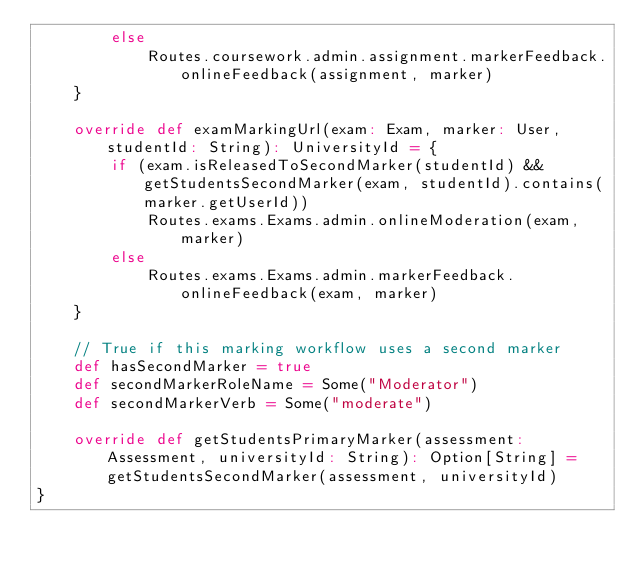<code> <loc_0><loc_0><loc_500><loc_500><_Scala_>		else
			Routes.coursework.admin.assignment.markerFeedback.onlineFeedback(assignment, marker)
	}

	override def examMarkingUrl(exam: Exam, marker: User, studentId: String): UniversityId = {
		if (exam.isReleasedToSecondMarker(studentId) && getStudentsSecondMarker(exam, studentId).contains(marker.getUserId))
			Routes.exams.Exams.admin.onlineModeration(exam, marker)
		else
			Routes.exams.Exams.admin.markerFeedback.onlineFeedback(exam, marker)
	}

	// True if this marking workflow uses a second marker
	def hasSecondMarker = true
	def secondMarkerRoleName = Some("Moderator")
	def secondMarkerVerb = Some("moderate")

	override def getStudentsPrimaryMarker(assessment: Assessment, universityId: String): Option[String] = getStudentsSecondMarker(assessment, universityId)
}
</code> 